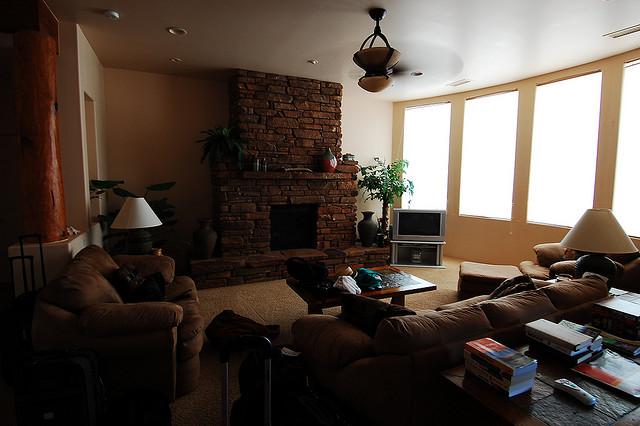Is it daytime or is it nighttime?
Be succinct. Daytime. How many lamps are in the room?
Keep it brief. 2. What material is the fireplace made out of?
Short answer required. Brick. 